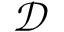Convert formula to latex. <formula><loc_0><loc_0><loc_500><loc_500>\mathcal { D }</formula> 